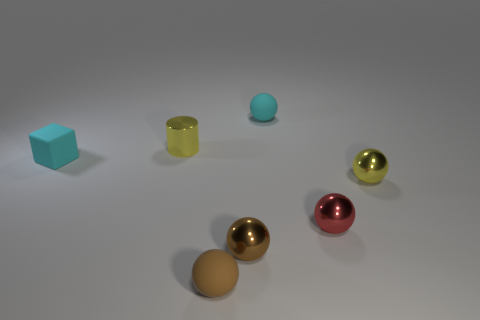What is the material of the cyan thing that is the same shape as the tiny red shiny object?
Offer a very short reply. Rubber. Are there an equal number of small cyan things that are left of the cylinder and small brown rubber things left of the tiny cyan matte cube?
Make the answer very short. No. Does the red ball have the same material as the yellow sphere?
Ensure brevity in your answer.  Yes. How many brown objects are either small metal things or things?
Make the answer very short. 2. How many other metal objects are the same shape as the small red thing?
Your answer should be very brief. 2. What material is the yellow cylinder?
Ensure brevity in your answer.  Metal. Is the number of small yellow shiny things behind the rubber block the same as the number of tiny green spheres?
Offer a very short reply. No. There is a brown matte object that is the same size as the red shiny ball; what is its shape?
Ensure brevity in your answer.  Sphere. There is a sphere behind the small block; are there any cyan objects in front of it?
Make the answer very short. Yes. How many big things are either yellow objects or brown shiny balls?
Ensure brevity in your answer.  0. 